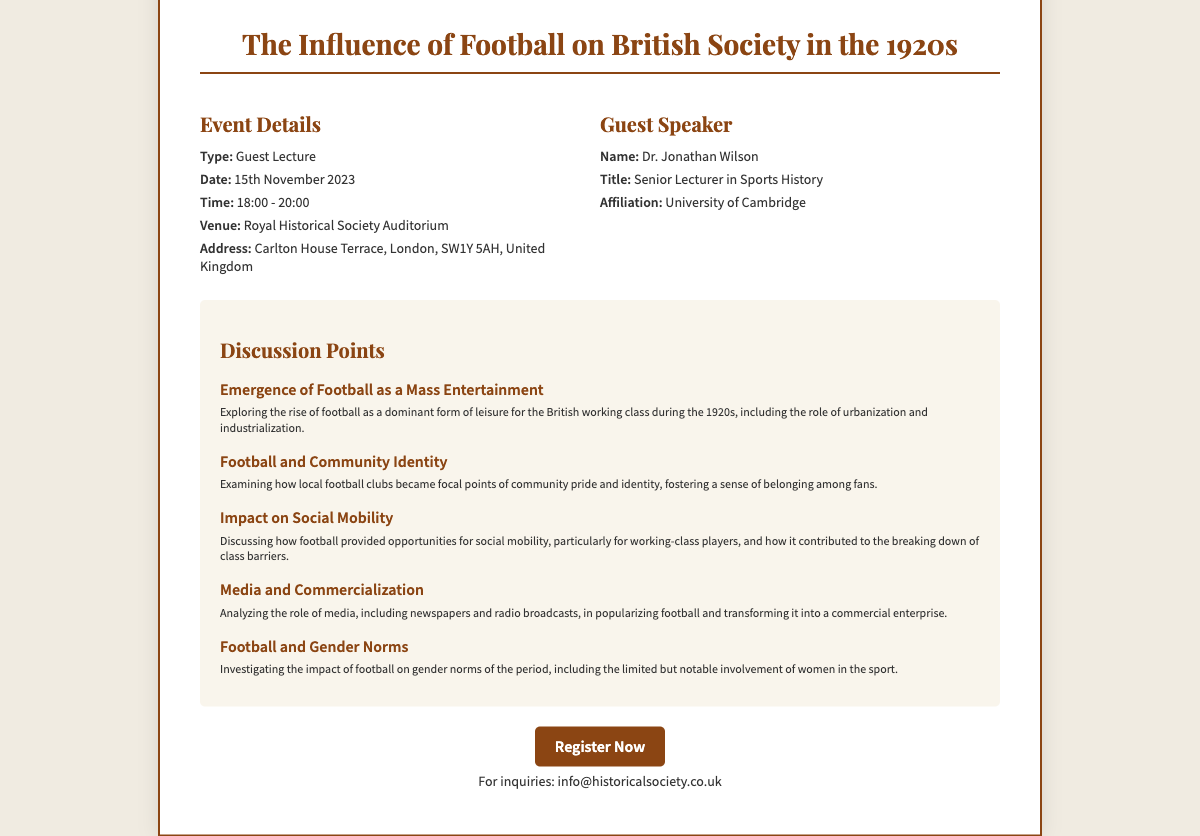What is the date of the lecture? The document states that the guest lecture is scheduled for 15th November 2023.
Answer: 15th November 2023 Who is the guest speaker? The document lists Dr. Jonathan Wilson as the guest speaker.
Answer: Dr. Jonathan Wilson What is the venue for the event? According to the document, the lecture will be held at the Royal Historical Society Auditorium.
Answer: Royal Historical Society Auditorium What is the primary topic of discussion regarding football? The document highlights the emergence of football as a dominant form of leisure for the British working class during the 1920s.
Answer: Emergence of Football as a Mass Entertainment What time does the lecture start? The ticket specifies that the lecture begins at 18:00.
Answer: 18:00 How long is the lecture scheduled to last? The document indicates the lecture lasts from 18:00 to 20:00, which is 2 hours.
Answer: 2 hours What is the affiliation of the guest speaker? The document states that Dr. Jonathan Wilson is affiliated with the University of Cambridge.
Answer: University of Cambridge What is one discussion point related to social mobility? The document mentions that football provided opportunities for social mobility, particularly for working-class players.
Answer: Impact on Social Mobility What type of event is this ticket for? The document categorizes the event as a guest lecture.
Answer: Guest Lecture 